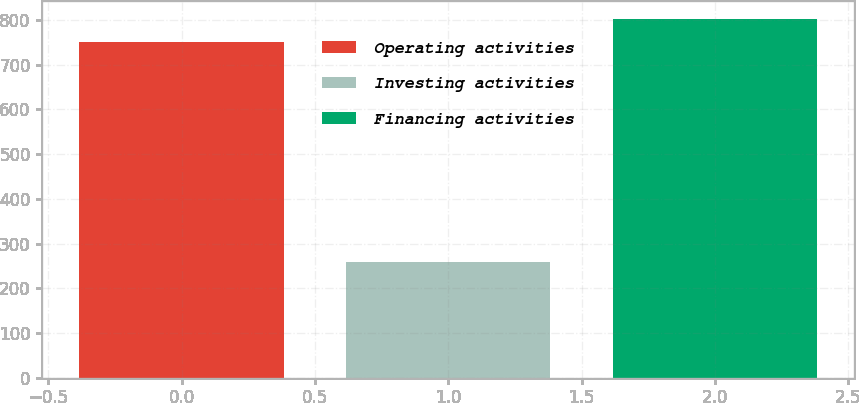Convert chart. <chart><loc_0><loc_0><loc_500><loc_500><bar_chart><fcel>Operating activities<fcel>Investing activities<fcel>Financing activities<nl><fcel>750<fcel>258<fcel>801.7<nl></chart> 